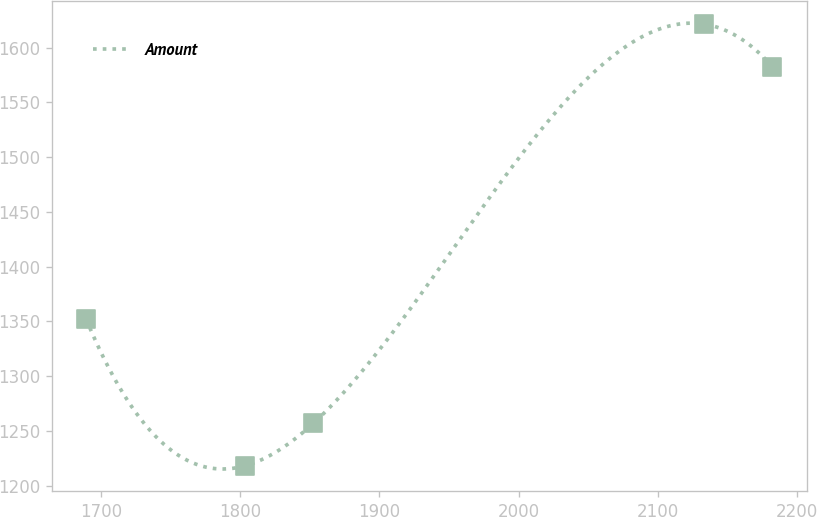<chart> <loc_0><loc_0><loc_500><loc_500><line_chart><ecel><fcel>Amount<nl><fcel>1689.39<fcel>1352.3<nl><fcel>1803.57<fcel>1218.04<nl><fcel>1852.54<fcel>1256.83<nl><fcel>2133.09<fcel>1621.56<nl><fcel>2182.06<fcel>1582.77<nl></chart> 